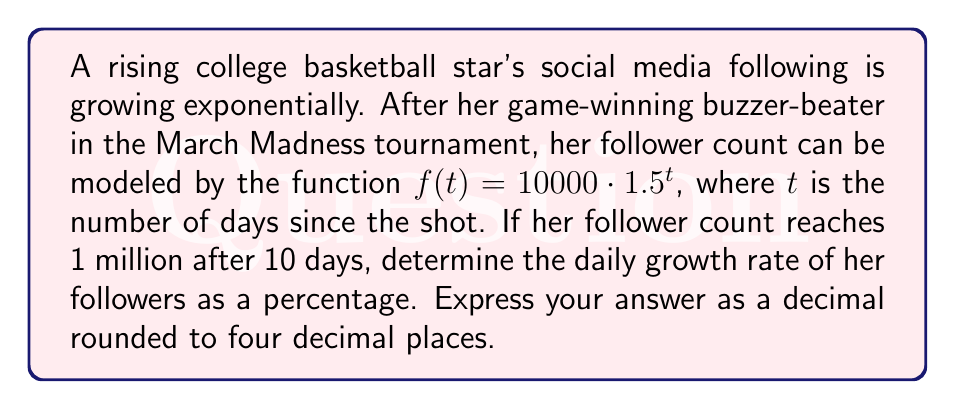Teach me how to tackle this problem. Let's approach this step-by-step, baby!

1) We're given the function $f(t) = 10000 \cdot 1.5^t$.

2) We know that after 10 days, the follower count reaches 1 million. We can express this as:

   $1000000 = 10000 \cdot 1.5^{10}$

3) To solve for the growth rate, we need to find $r$ in the general exponential growth formula:

   $f(t) = a \cdot (1+r)^t$

   Where $a$ is the initial value and $r$ is the daily growth rate.

4) Comparing our given function to this general form, we can see that:

   $1.5 = 1 + r$

5) Solving for $r$:

   $r = 1.5 - 1 = 0.5$

6) To convert to a percentage, we multiply by 100:

   $0.5 \cdot 100 = 50\%$

7) The question asks for the answer as a decimal rounded to four decimal places, so our final answer is 0.5000.

It's a slam dunk, baby! The player's social media is on fire, just like her performance on the court!
Answer: 0.5000 